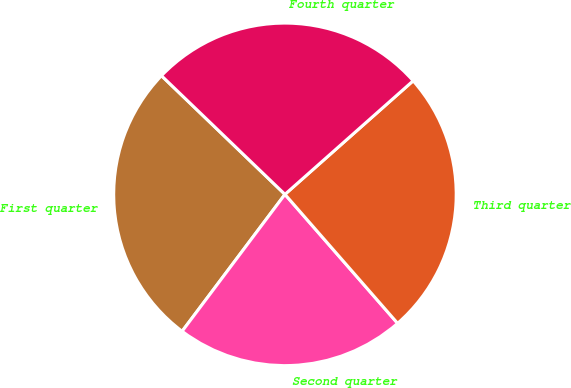Convert chart to OTSL. <chart><loc_0><loc_0><loc_500><loc_500><pie_chart><fcel>First quarter<fcel>Second quarter<fcel>Third quarter<fcel>Fourth quarter<nl><fcel>26.93%<fcel>21.68%<fcel>25.11%<fcel>26.28%<nl></chart> 